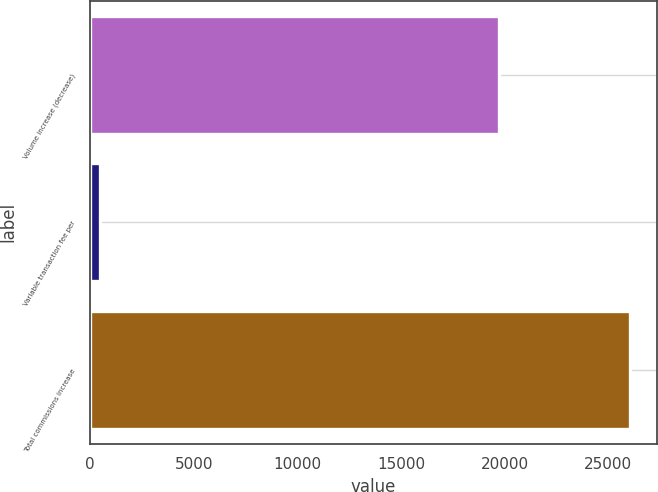<chart> <loc_0><loc_0><loc_500><loc_500><bar_chart><fcel>Volume increase (decrease)<fcel>Variable transaction fee per<fcel>Total commissions increase<nl><fcel>19725<fcel>480<fcel>26048<nl></chart> 